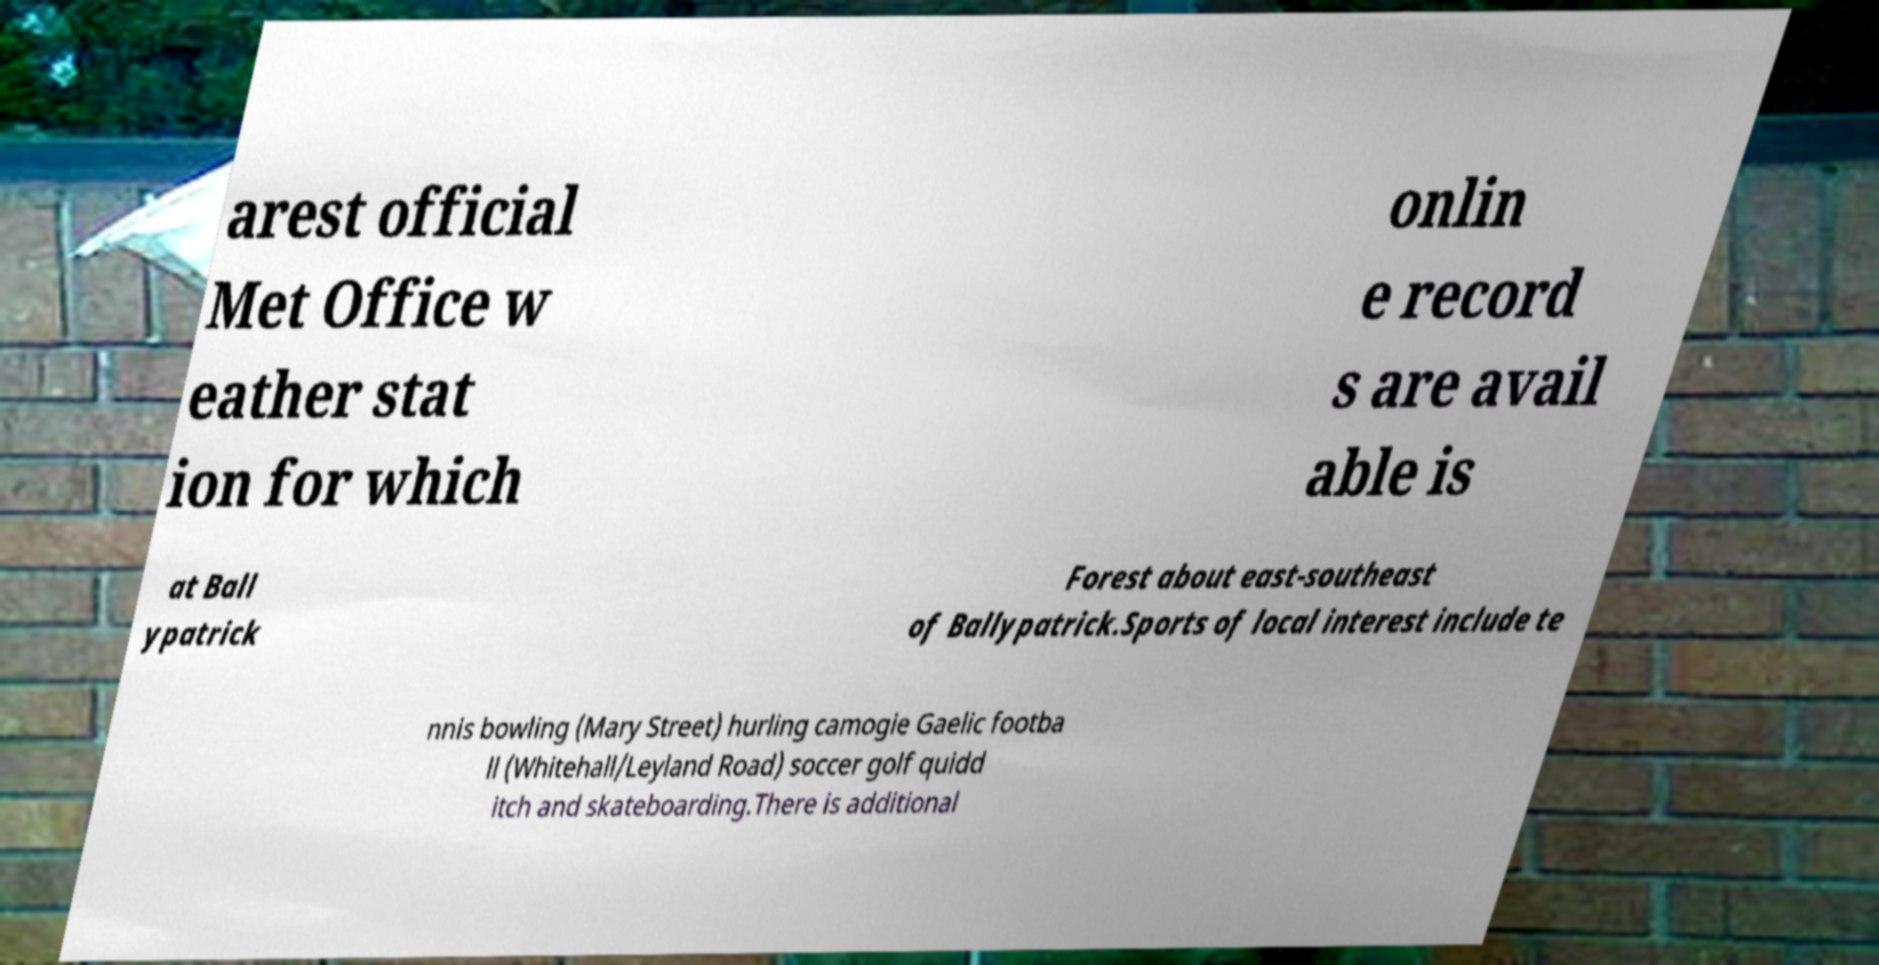Can you read and provide the text displayed in the image?This photo seems to have some interesting text. Can you extract and type it out for me? arest official Met Office w eather stat ion for which onlin e record s are avail able is at Ball ypatrick Forest about east-southeast of Ballypatrick.Sports of local interest include te nnis bowling (Mary Street) hurling camogie Gaelic footba ll (Whitehall/Leyland Road) soccer golf quidd itch and skateboarding.There is additional 